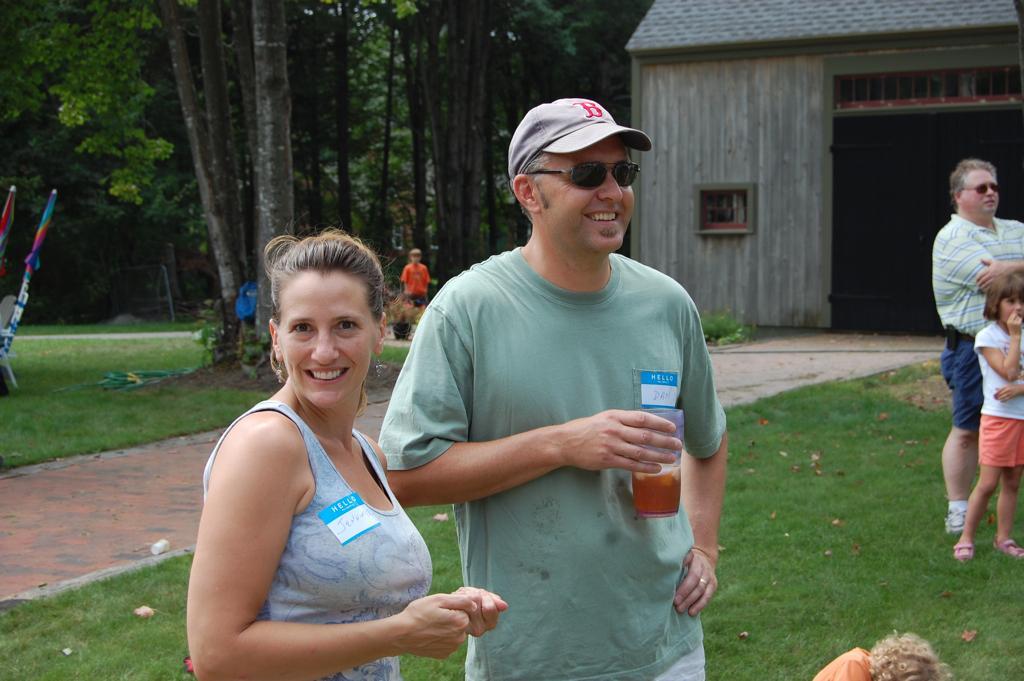Can you describe this image briefly? In this picture I can see there is a man and woman standing here and they are smiling, the man is holding the glass and there is a sticker pasted on their shirts. On to right side there is a man and a girl standing. In the backdrop there is a building, trees and a boy is standing near trees, he is wearing a orange color shirt. 